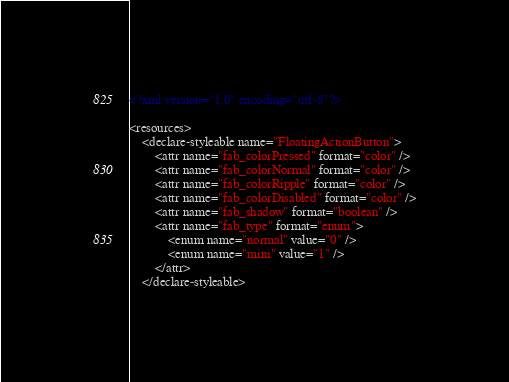<code> <loc_0><loc_0><loc_500><loc_500><_XML_><?xml version="1.0" encoding="utf-8"?>

<resources>
    <declare-styleable name="FloatingActionButton">
        <attr name="fab_colorPressed" format="color" />
        <attr name="fab_colorNormal" format="color" />
        <attr name="fab_colorRipple" format="color" />
        <attr name="fab_colorDisabled" format="color" />
        <attr name="fab_shadow" format="boolean" />
        <attr name="fab_type" format="enum">
            <enum name="normal" value="0" />
            <enum name="mini" value="1" />
        </attr>
    </declare-styleable></code> 